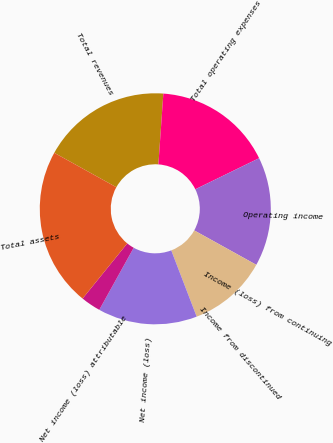<chart> <loc_0><loc_0><loc_500><loc_500><pie_chart><fcel>Total revenues<fcel>Total operating expenses<fcel>Operating income<fcel>Income (loss) from continuing<fcel>Income from discontinued<fcel>Net income (loss)<fcel>Net income (loss) attributable<fcel>Total assets<nl><fcel>18.06%<fcel>16.67%<fcel>15.28%<fcel>0.0%<fcel>11.11%<fcel>13.89%<fcel>2.78%<fcel>22.22%<nl></chart> 